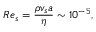Convert formula to latex. <formula><loc_0><loc_0><loc_500><loc_500>R e _ { s } = \frac { \rho v _ { s } a } { \eta } \sim 1 0 ^ { - 5 } ,</formula> 